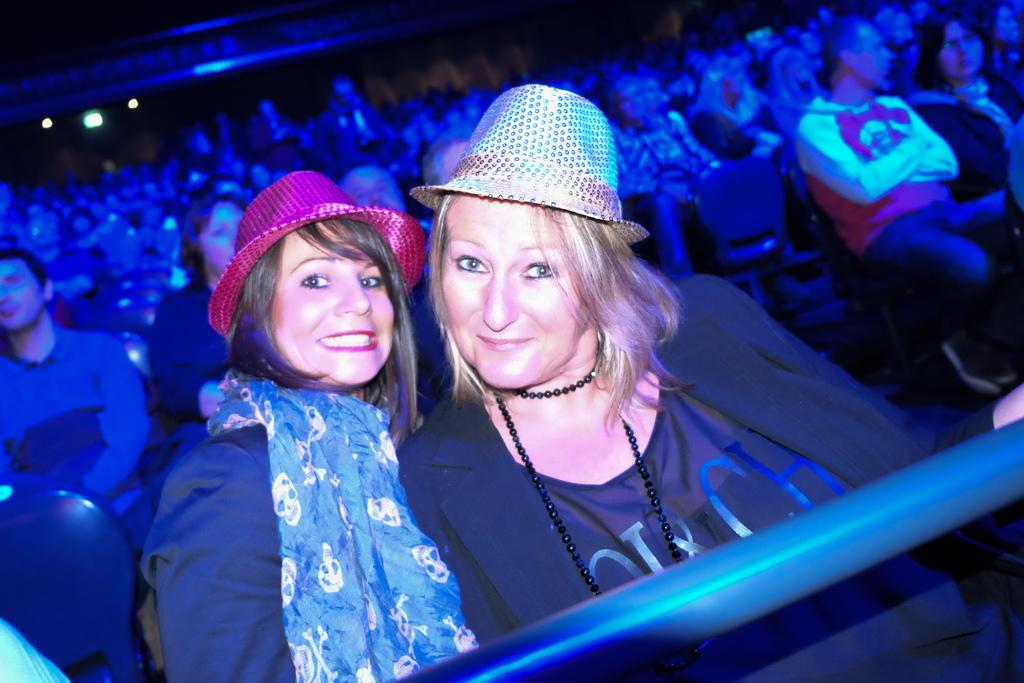What are the people in the image doing? There are people sitting on chairs in the image. What is in front of the women in the image? There is a rod in front of the women. Can you describe the background of the image? The background of the image is blurred. What are the women wearing on their heads? The two women in the image are wearing hats. What can be seen in the distance in the image? There are lights visible in the distance. How many tickets does the chicken have in the image? There is no chicken present in the image, so it is not possible to determine how many tickets it might have. 